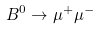Convert formula to latex. <formula><loc_0><loc_0><loc_500><loc_500>B ^ { 0 } \rightarrow \mu ^ { + } \mu ^ { - }</formula> 